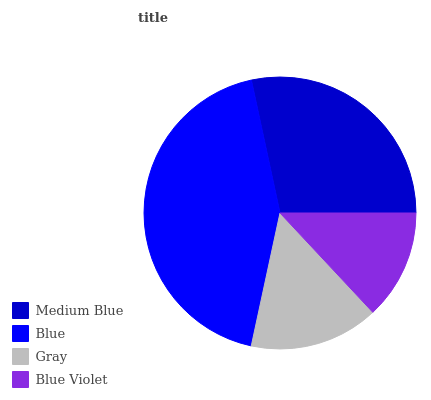Is Blue Violet the minimum?
Answer yes or no. Yes. Is Blue the maximum?
Answer yes or no. Yes. Is Gray the minimum?
Answer yes or no. No. Is Gray the maximum?
Answer yes or no. No. Is Blue greater than Gray?
Answer yes or no. Yes. Is Gray less than Blue?
Answer yes or no. Yes. Is Gray greater than Blue?
Answer yes or no. No. Is Blue less than Gray?
Answer yes or no. No. Is Medium Blue the high median?
Answer yes or no. Yes. Is Gray the low median?
Answer yes or no. Yes. Is Gray the high median?
Answer yes or no. No. Is Medium Blue the low median?
Answer yes or no. No. 